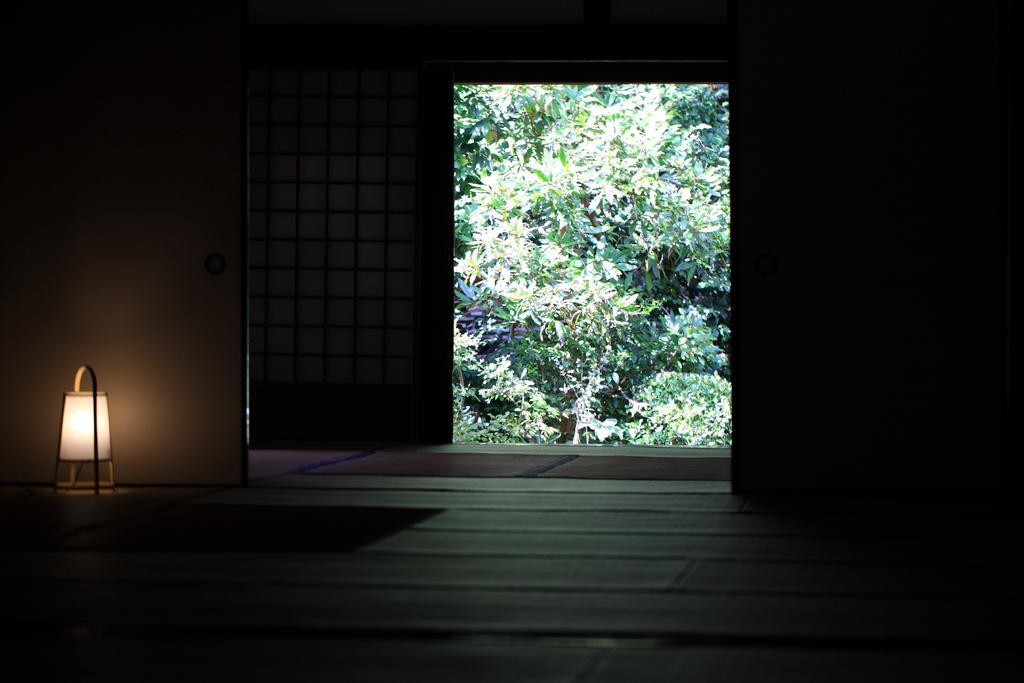Can you describe this image briefly? Here in this picture, on the left side we can see a lamp present and in the middle we can see door present, which is opened and through that we can see plants and trees present outside. 